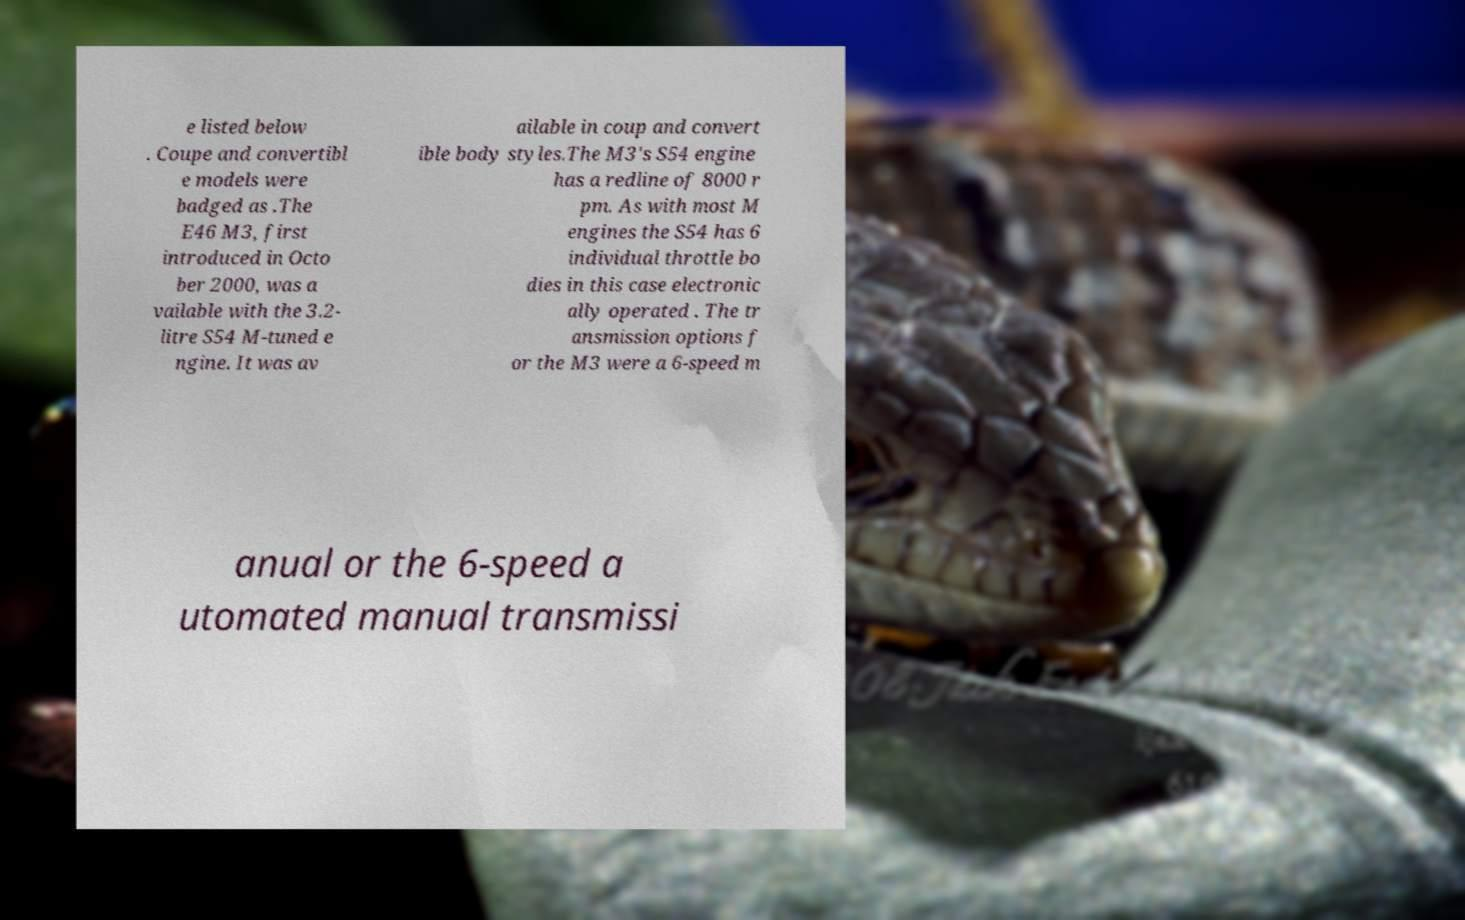Can you read and provide the text displayed in the image?This photo seems to have some interesting text. Can you extract and type it out for me? e listed below . Coupe and convertibl e models were badged as .The E46 M3, first introduced in Octo ber 2000, was a vailable with the 3.2- litre S54 M-tuned e ngine. It was av ailable in coup and convert ible body styles.The M3's S54 engine has a redline of 8000 r pm. As with most M engines the S54 has 6 individual throttle bo dies in this case electronic ally operated . The tr ansmission options f or the M3 were a 6-speed m anual or the 6-speed a utomated manual transmissi 